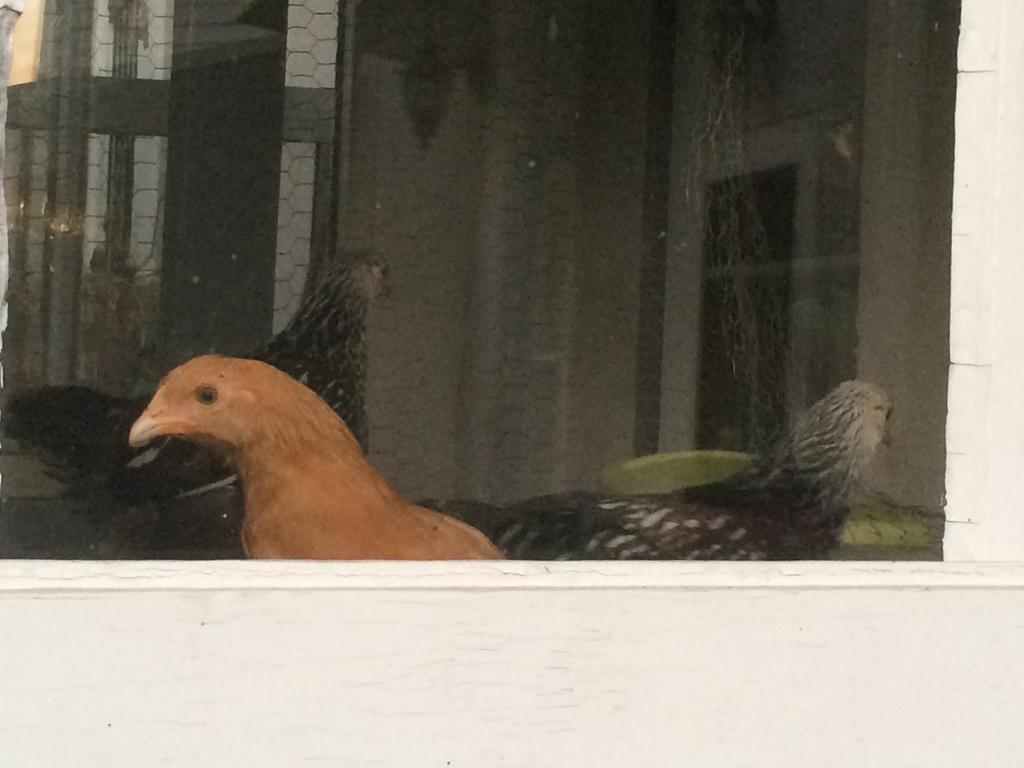What type of animals can be seen in the image? There are hens visible in the image. Where are the hens located in relation to the viewer? The hens are visible through a window. What is the color of the surface around the window in the image? There is a white surface around the window in the image. What type of brake system can be seen on the hens in the image? There is no brake system present on the hens in the image, as they are animals and not vehicles. 